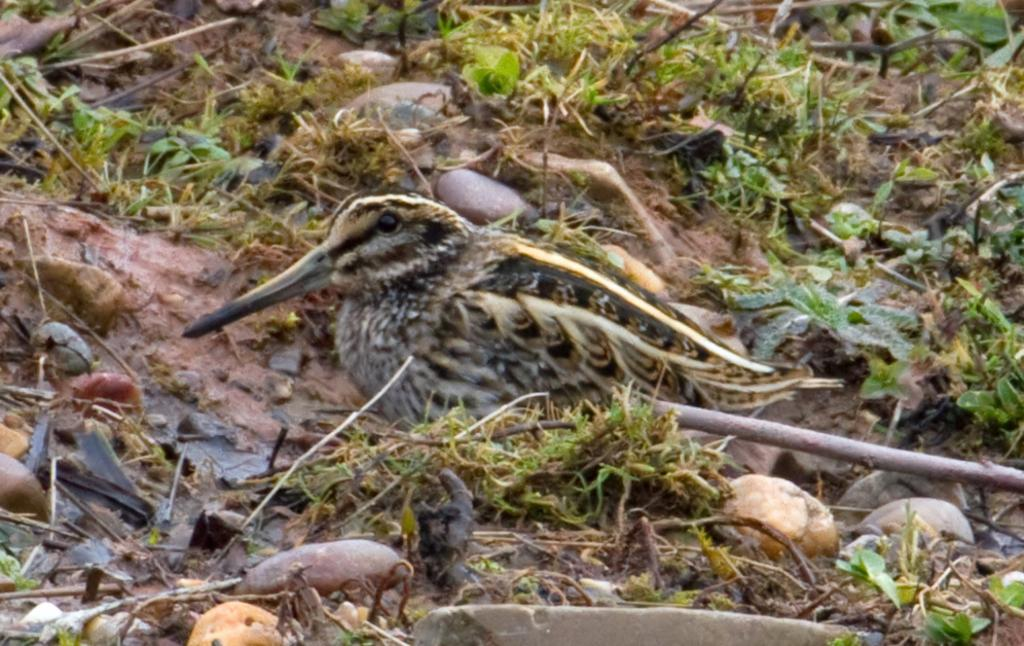What type of animal is standing in the image? There is a bird standing in the image. What can be seen growing in the image? There are stems in the image. What type of natural material is present in the image? There are stones in the image. What type of vegetation is visible in the image? There is grass in the image. Who is the owner of the bird in the image? There is no indication of ownership in the image, and the bird's owner cannot be determined. 